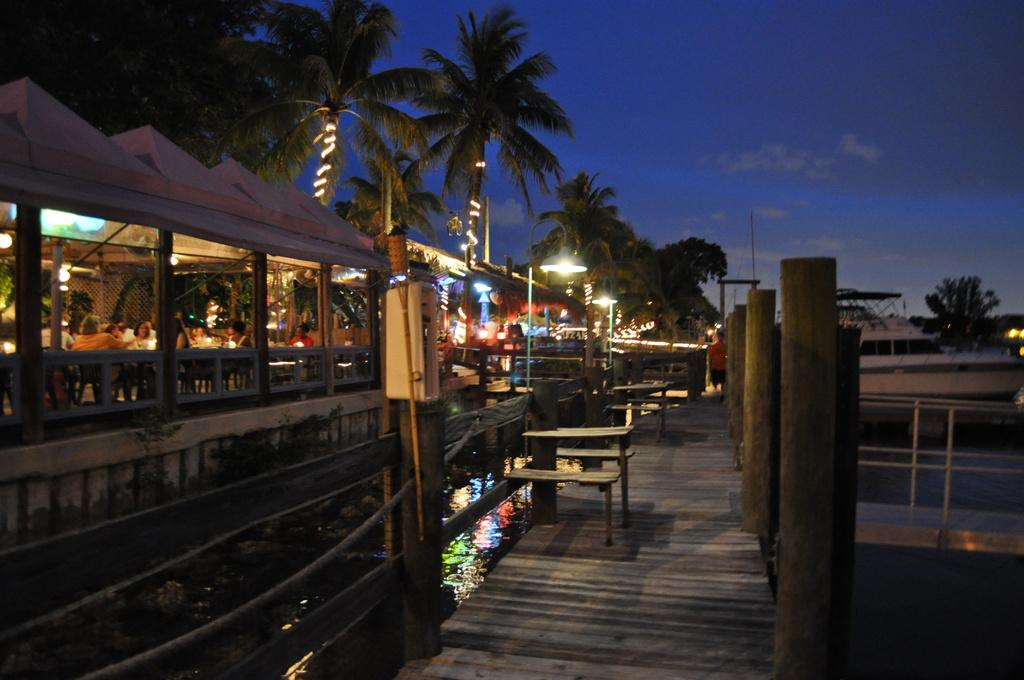What type of setting is depicted in the image? The image has an outside view. What is located in the foreground of the image? There is a restaurant in the foreground. What type of seating can be seen in the middle of the image? There are benches in the middle of the image. What can be seen in the background of the image? There are trees and the sky visible in the background. What is the name of the daughter who is playing on the swings in the park in the image? There is no daughter or park present in the image; it features an outdoor view with a restaurant, benches, trees, and the sky. 